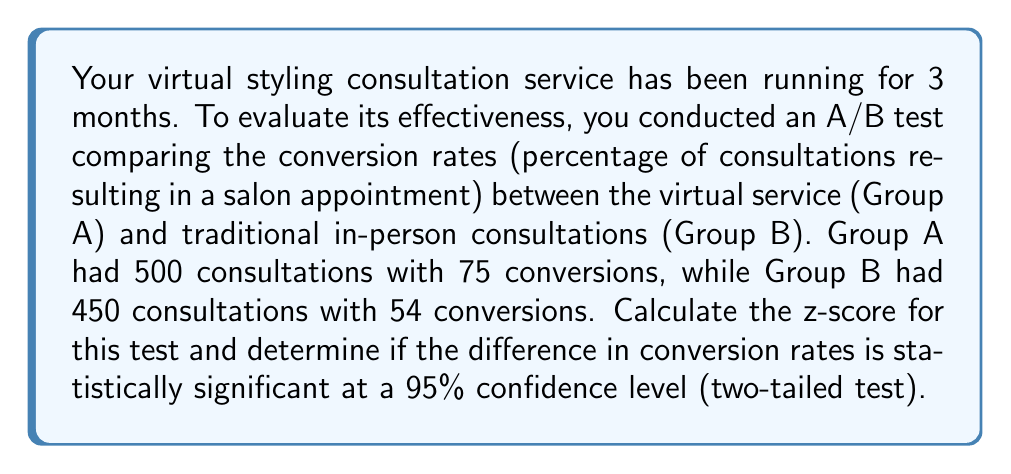Provide a solution to this math problem. To solve this problem, we'll follow these steps:

1. Calculate the conversion rates for both groups
2. Calculate the pooled proportion
3. Calculate the standard error
4. Calculate the z-score
5. Determine statistical significance

Step 1: Calculate conversion rates

Group A (Virtual): $p_A = \frac{75}{500} = 0.15$ or 15%
Group B (In-person): $p_B = \frac{54}{450} = 0.12$ or 12%

Step 2: Calculate the pooled proportion

$$p = \frac{n_A p_A + n_B p_B}{n_A + n_B} = \frac{500(0.15) + 450(0.12)}{500 + 450} = \frac{129}{950} \approx 0.1358$$

Step 3: Calculate the standard error

$$SE = \sqrt{p(1-p)(\frac{1}{n_A} + \frac{1}{n_B})} = \sqrt{0.1358(1-0.1358)(\frac{1}{500} + \frac{1}{450})} \approx 0.0217$$

Step 4: Calculate the z-score

$$z = \frac{p_A - p_B}{SE} = \frac{0.15 - 0.12}{0.0217} \approx 1.3824$$

Step 5: Determine statistical significance

For a 95% confidence level in a two-tailed test, the critical z-value is ±1.96. Since our calculated z-score (1.3824) is less than 1.96, we cannot reject the null hypothesis.
Answer: The z-score is approximately 1.3824. The difference in conversion rates between virtual and in-person consultations is not statistically significant at a 95% confidence level. 